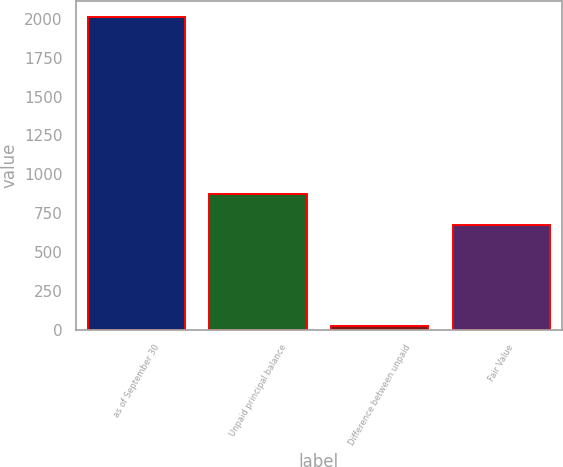Convert chart to OTSL. <chart><loc_0><loc_0><loc_500><loc_500><bar_chart><fcel>as of September 30<fcel>Unpaid principal balance<fcel>Difference between unpaid<fcel>Fair Value<nl><fcel>2015<fcel>871.8<fcel>22<fcel>672.5<nl></chart> 